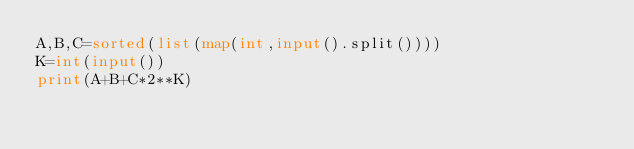Convert code to text. <code><loc_0><loc_0><loc_500><loc_500><_Python_>A,B,C=sorted(list(map(int,input().split())))
K=int(input())
print(A+B+C*2**K)</code> 